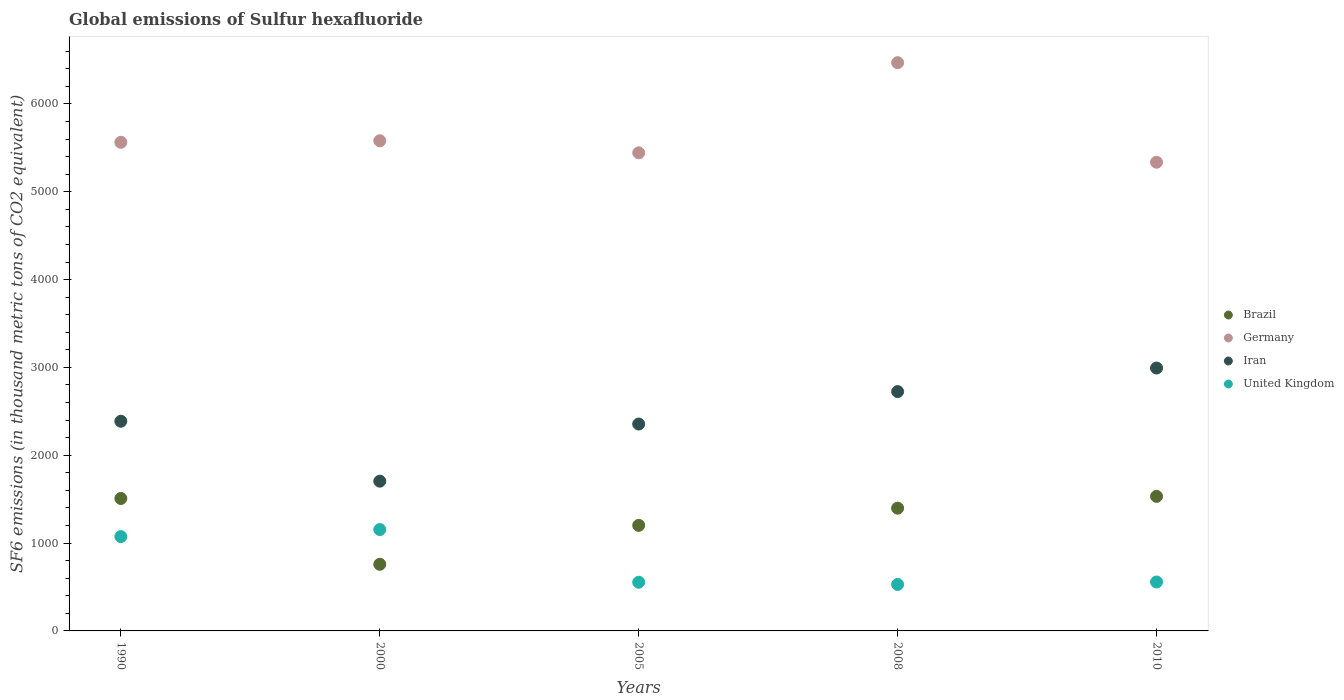How many different coloured dotlines are there?
Your answer should be very brief. 4. What is the global emissions of Sulfur hexafluoride in United Kingdom in 1990?
Your response must be concise. 1073.9. Across all years, what is the maximum global emissions of Sulfur hexafluoride in Iran?
Keep it short and to the point. 2993. Across all years, what is the minimum global emissions of Sulfur hexafluoride in Brazil?
Keep it short and to the point. 758.7. In which year was the global emissions of Sulfur hexafluoride in Brazil maximum?
Provide a short and direct response. 2010. In which year was the global emissions of Sulfur hexafluoride in Brazil minimum?
Ensure brevity in your answer.  2000. What is the total global emissions of Sulfur hexafluoride in Germany in the graph?
Your response must be concise. 2.84e+04. What is the difference between the global emissions of Sulfur hexafluoride in Germany in 2000 and that in 2005?
Provide a succinct answer. 137.2. What is the difference between the global emissions of Sulfur hexafluoride in Brazil in 2005 and the global emissions of Sulfur hexafluoride in Germany in 2010?
Provide a short and direct response. -4134. What is the average global emissions of Sulfur hexafluoride in Iran per year?
Your answer should be compact. 2433.12. In the year 2010, what is the difference between the global emissions of Sulfur hexafluoride in United Kingdom and global emissions of Sulfur hexafluoride in Germany?
Ensure brevity in your answer.  -4779. In how many years, is the global emissions of Sulfur hexafluoride in Brazil greater than 6400 thousand metric tons?
Offer a terse response. 0. What is the ratio of the global emissions of Sulfur hexafluoride in Iran in 2000 to that in 2005?
Offer a terse response. 0.72. Is the global emissions of Sulfur hexafluoride in Germany in 2000 less than that in 2010?
Offer a very short reply. No. What is the difference between the highest and the second highest global emissions of Sulfur hexafluoride in United Kingdom?
Give a very brief answer. 80.2. What is the difference between the highest and the lowest global emissions of Sulfur hexafluoride in Brazil?
Provide a short and direct response. 773.3. Is it the case that in every year, the sum of the global emissions of Sulfur hexafluoride in Iran and global emissions of Sulfur hexafluoride in Germany  is greater than the global emissions of Sulfur hexafluoride in United Kingdom?
Your response must be concise. Yes. Is the global emissions of Sulfur hexafluoride in United Kingdom strictly greater than the global emissions of Sulfur hexafluoride in Germany over the years?
Offer a terse response. No. Is the global emissions of Sulfur hexafluoride in Brazil strictly less than the global emissions of Sulfur hexafluoride in Germany over the years?
Your answer should be very brief. Yes. How many dotlines are there?
Offer a very short reply. 4. How many years are there in the graph?
Give a very brief answer. 5. What is the difference between two consecutive major ticks on the Y-axis?
Your answer should be compact. 1000. Does the graph contain any zero values?
Provide a succinct answer. No. Does the graph contain grids?
Make the answer very short. No. Where does the legend appear in the graph?
Keep it short and to the point. Center right. What is the title of the graph?
Your response must be concise. Global emissions of Sulfur hexafluoride. Does "Egypt, Arab Rep." appear as one of the legend labels in the graph?
Make the answer very short. No. What is the label or title of the Y-axis?
Offer a very short reply. SF6 emissions (in thousand metric tons of CO2 equivalent). What is the SF6 emissions (in thousand metric tons of CO2 equivalent) of Brazil in 1990?
Your answer should be very brief. 1507.9. What is the SF6 emissions (in thousand metric tons of CO2 equivalent) of Germany in 1990?
Provide a succinct answer. 5562.9. What is the SF6 emissions (in thousand metric tons of CO2 equivalent) of Iran in 1990?
Give a very brief answer. 2387.3. What is the SF6 emissions (in thousand metric tons of CO2 equivalent) in United Kingdom in 1990?
Your response must be concise. 1073.9. What is the SF6 emissions (in thousand metric tons of CO2 equivalent) of Brazil in 2000?
Your answer should be very brief. 758.7. What is the SF6 emissions (in thousand metric tons of CO2 equivalent) of Germany in 2000?
Your answer should be compact. 5580.4. What is the SF6 emissions (in thousand metric tons of CO2 equivalent) of Iran in 2000?
Provide a succinct answer. 1704.9. What is the SF6 emissions (in thousand metric tons of CO2 equivalent) in United Kingdom in 2000?
Offer a terse response. 1154.1. What is the SF6 emissions (in thousand metric tons of CO2 equivalent) in Brazil in 2005?
Your answer should be very brief. 1202. What is the SF6 emissions (in thousand metric tons of CO2 equivalent) in Germany in 2005?
Your answer should be compact. 5443.2. What is the SF6 emissions (in thousand metric tons of CO2 equivalent) in Iran in 2005?
Provide a succinct answer. 2355.5. What is the SF6 emissions (in thousand metric tons of CO2 equivalent) of United Kingdom in 2005?
Your answer should be very brief. 554.2. What is the SF6 emissions (in thousand metric tons of CO2 equivalent) of Brazil in 2008?
Ensure brevity in your answer.  1397.3. What is the SF6 emissions (in thousand metric tons of CO2 equivalent) in Germany in 2008?
Make the answer very short. 6469.6. What is the SF6 emissions (in thousand metric tons of CO2 equivalent) in Iran in 2008?
Your answer should be compact. 2724.9. What is the SF6 emissions (in thousand metric tons of CO2 equivalent) in United Kingdom in 2008?
Give a very brief answer. 528.9. What is the SF6 emissions (in thousand metric tons of CO2 equivalent) of Brazil in 2010?
Offer a very short reply. 1532. What is the SF6 emissions (in thousand metric tons of CO2 equivalent) in Germany in 2010?
Your answer should be compact. 5336. What is the SF6 emissions (in thousand metric tons of CO2 equivalent) in Iran in 2010?
Ensure brevity in your answer.  2993. What is the SF6 emissions (in thousand metric tons of CO2 equivalent) of United Kingdom in 2010?
Your answer should be compact. 557. Across all years, what is the maximum SF6 emissions (in thousand metric tons of CO2 equivalent) in Brazil?
Offer a terse response. 1532. Across all years, what is the maximum SF6 emissions (in thousand metric tons of CO2 equivalent) in Germany?
Offer a very short reply. 6469.6. Across all years, what is the maximum SF6 emissions (in thousand metric tons of CO2 equivalent) of Iran?
Offer a terse response. 2993. Across all years, what is the maximum SF6 emissions (in thousand metric tons of CO2 equivalent) in United Kingdom?
Offer a very short reply. 1154.1. Across all years, what is the minimum SF6 emissions (in thousand metric tons of CO2 equivalent) in Brazil?
Make the answer very short. 758.7. Across all years, what is the minimum SF6 emissions (in thousand metric tons of CO2 equivalent) of Germany?
Provide a succinct answer. 5336. Across all years, what is the minimum SF6 emissions (in thousand metric tons of CO2 equivalent) in Iran?
Provide a short and direct response. 1704.9. Across all years, what is the minimum SF6 emissions (in thousand metric tons of CO2 equivalent) of United Kingdom?
Give a very brief answer. 528.9. What is the total SF6 emissions (in thousand metric tons of CO2 equivalent) in Brazil in the graph?
Offer a very short reply. 6397.9. What is the total SF6 emissions (in thousand metric tons of CO2 equivalent) of Germany in the graph?
Your answer should be very brief. 2.84e+04. What is the total SF6 emissions (in thousand metric tons of CO2 equivalent) of Iran in the graph?
Offer a terse response. 1.22e+04. What is the total SF6 emissions (in thousand metric tons of CO2 equivalent) in United Kingdom in the graph?
Offer a terse response. 3868.1. What is the difference between the SF6 emissions (in thousand metric tons of CO2 equivalent) of Brazil in 1990 and that in 2000?
Make the answer very short. 749.2. What is the difference between the SF6 emissions (in thousand metric tons of CO2 equivalent) in Germany in 1990 and that in 2000?
Your answer should be compact. -17.5. What is the difference between the SF6 emissions (in thousand metric tons of CO2 equivalent) in Iran in 1990 and that in 2000?
Ensure brevity in your answer.  682.4. What is the difference between the SF6 emissions (in thousand metric tons of CO2 equivalent) of United Kingdom in 1990 and that in 2000?
Offer a very short reply. -80.2. What is the difference between the SF6 emissions (in thousand metric tons of CO2 equivalent) in Brazil in 1990 and that in 2005?
Your answer should be compact. 305.9. What is the difference between the SF6 emissions (in thousand metric tons of CO2 equivalent) of Germany in 1990 and that in 2005?
Provide a succinct answer. 119.7. What is the difference between the SF6 emissions (in thousand metric tons of CO2 equivalent) of Iran in 1990 and that in 2005?
Your answer should be compact. 31.8. What is the difference between the SF6 emissions (in thousand metric tons of CO2 equivalent) in United Kingdom in 1990 and that in 2005?
Your answer should be compact. 519.7. What is the difference between the SF6 emissions (in thousand metric tons of CO2 equivalent) of Brazil in 1990 and that in 2008?
Make the answer very short. 110.6. What is the difference between the SF6 emissions (in thousand metric tons of CO2 equivalent) in Germany in 1990 and that in 2008?
Offer a terse response. -906.7. What is the difference between the SF6 emissions (in thousand metric tons of CO2 equivalent) in Iran in 1990 and that in 2008?
Make the answer very short. -337.6. What is the difference between the SF6 emissions (in thousand metric tons of CO2 equivalent) in United Kingdom in 1990 and that in 2008?
Keep it short and to the point. 545. What is the difference between the SF6 emissions (in thousand metric tons of CO2 equivalent) in Brazil in 1990 and that in 2010?
Make the answer very short. -24.1. What is the difference between the SF6 emissions (in thousand metric tons of CO2 equivalent) in Germany in 1990 and that in 2010?
Provide a succinct answer. 226.9. What is the difference between the SF6 emissions (in thousand metric tons of CO2 equivalent) of Iran in 1990 and that in 2010?
Provide a short and direct response. -605.7. What is the difference between the SF6 emissions (in thousand metric tons of CO2 equivalent) of United Kingdom in 1990 and that in 2010?
Give a very brief answer. 516.9. What is the difference between the SF6 emissions (in thousand metric tons of CO2 equivalent) in Brazil in 2000 and that in 2005?
Provide a succinct answer. -443.3. What is the difference between the SF6 emissions (in thousand metric tons of CO2 equivalent) in Germany in 2000 and that in 2005?
Offer a terse response. 137.2. What is the difference between the SF6 emissions (in thousand metric tons of CO2 equivalent) in Iran in 2000 and that in 2005?
Provide a short and direct response. -650.6. What is the difference between the SF6 emissions (in thousand metric tons of CO2 equivalent) in United Kingdom in 2000 and that in 2005?
Offer a very short reply. 599.9. What is the difference between the SF6 emissions (in thousand metric tons of CO2 equivalent) in Brazil in 2000 and that in 2008?
Your answer should be compact. -638.6. What is the difference between the SF6 emissions (in thousand metric tons of CO2 equivalent) in Germany in 2000 and that in 2008?
Provide a short and direct response. -889.2. What is the difference between the SF6 emissions (in thousand metric tons of CO2 equivalent) in Iran in 2000 and that in 2008?
Provide a succinct answer. -1020. What is the difference between the SF6 emissions (in thousand metric tons of CO2 equivalent) in United Kingdom in 2000 and that in 2008?
Ensure brevity in your answer.  625.2. What is the difference between the SF6 emissions (in thousand metric tons of CO2 equivalent) of Brazil in 2000 and that in 2010?
Give a very brief answer. -773.3. What is the difference between the SF6 emissions (in thousand metric tons of CO2 equivalent) of Germany in 2000 and that in 2010?
Make the answer very short. 244.4. What is the difference between the SF6 emissions (in thousand metric tons of CO2 equivalent) in Iran in 2000 and that in 2010?
Your response must be concise. -1288.1. What is the difference between the SF6 emissions (in thousand metric tons of CO2 equivalent) of United Kingdom in 2000 and that in 2010?
Offer a very short reply. 597.1. What is the difference between the SF6 emissions (in thousand metric tons of CO2 equivalent) of Brazil in 2005 and that in 2008?
Your answer should be compact. -195.3. What is the difference between the SF6 emissions (in thousand metric tons of CO2 equivalent) in Germany in 2005 and that in 2008?
Ensure brevity in your answer.  -1026.4. What is the difference between the SF6 emissions (in thousand metric tons of CO2 equivalent) in Iran in 2005 and that in 2008?
Your response must be concise. -369.4. What is the difference between the SF6 emissions (in thousand metric tons of CO2 equivalent) in United Kingdom in 2005 and that in 2008?
Ensure brevity in your answer.  25.3. What is the difference between the SF6 emissions (in thousand metric tons of CO2 equivalent) of Brazil in 2005 and that in 2010?
Provide a succinct answer. -330. What is the difference between the SF6 emissions (in thousand metric tons of CO2 equivalent) in Germany in 2005 and that in 2010?
Your answer should be very brief. 107.2. What is the difference between the SF6 emissions (in thousand metric tons of CO2 equivalent) of Iran in 2005 and that in 2010?
Your answer should be very brief. -637.5. What is the difference between the SF6 emissions (in thousand metric tons of CO2 equivalent) in Brazil in 2008 and that in 2010?
Your response must be concise. -134.7. What is the difference between the SF6 emissions (in thousand metric tons of CO2 equivalent) in Germany in 2008 and that in 2010?
Offer a terse response. 1133.6. What is the difference between the SF6 emissions (in thousand metric tons of CO2 equivalent) in Iran in 2008 and that in 2010?
Provide a short and direct response. -268.1. What is the difference between the SF6 emissions (in thousand metric tons of CO2 equivalent) in United Kingdom in 2008 and that in 2010?
Ensure brevity in your answer.  -28.1. What is the difference between the SF6 emissions (in thousand metric tons of CO2 equivalent) of Brazil in 1990 and the SF6 emissions (in thousand metric tons of CO2 equivalent) of Germany in 2000?
Your answer should be very brief. -4072.5. What is the difference between the SF6 emissions (in thousand metric tons of CO2 equivalent) in Brazil in 1990 and the SF6 emissions (in thousand metric tons of CO2 equivalent) in Iran in 2000?
Provide a succinct answer. -197. What is the difference between the SF6 emissions (in thousand metric tons of CO2 equivalent) of Brazil in 1990 and the SF6 emissions (in thousand metric tons of CO2 equivalent) of United Kingdom in 2000?
Your answer should be compact. 353.8. What is the difference between the SF6 emissions (in thousand metric tons of CO2 equivalent) in Germany in 1990 and the SF6 emissions (in thousand metric tons of CO2 equivalent) in Iran in 2000?
Provide a short and direct response. 3858. What is the difference between the SF6 emissions (in thousand metric tons of CO2 equivalent) of Germany in 1990 and the SF6 emissions (in thousand metric tons of CO2 equivalent) of United Kingdom in 2000?
Offer a very short reply. 4408.8. What is the difference between the SF6 emissions (in thousand metric tons of CO2 equivalent) of Iran in 1990 and the SF6 emissions (in thousand metric tons of CO2 equivalent) of United Kingdom in 2000?
Your answer should be very brief. 1233.2. What is the difference between the SF6 emissions (in thousand metric tons of CO2 equivalent) in Brazil in 1990 and the SF6 emissions (in thousand metric tons of CO2 equivalent) in Germany in 2005?
Provide a short and direct response. -3935.3. What is the difference between the SF6 emissions (in thousand metric tons of CO2 equivalent) of Brazil in 1990 and the SF6 emissions (in thousand metric tons of CO2 equivalent) of Iran in 2005?
Make the answer very short. -847.6. What is the difference between the SF6 emissions (in thousand metric tons of CO2 equivalent) of Brazil in 1990 and the SF6 emissions (in thousand metric tons of CO2 equivalent) of United Kingdom in 2005?
Your response must be concise. 953.7. What is the difference between the SF6 emissions (in thousand metric tons of CO2 equivalent) in Germany in 1990 and the SF6 emissions (in thousand metric tons of CO2 equivalent) in Iran in 2005?
Provide a short and direct response. 3207.4. What is the difference between the SF6 emissions (in thousand metric tons of CO2 equivalent) of Germany in 1990 and the SF6 emissions (in thousand metric tons of CO2 equivalent) of United Kingdom in 2005?
Offer a very short reply. 5008.7. What is the difference between the SF6 emissions (in thousand metric tons of CO2 equivalent) of Iran in 1990 and the SF6 emissions (in thousand metric tons of CO2 equivalent) of United Kingdom in 2005?
Provide a succinct answer. 1833.1. What is the difference between the SF6 emissions (in thousand metric tons of CO2 equivalent) in Brazil in 1990 and the SF6 emissions (in thousand metric tons of CO2 equivalent) in Germany in 2008?
Your response must be concise. -4961.7. What is the difference between the SF6 emissions (in thousand metric tons of CO2 equivalent) of Brazil in 1990 and the SF6 emissions (in thousand metric tons of CO2 equivalent) of Iran in 2008?
Provide a succinct answer. -1217. What is the difference between the SF6 emissions (in thousand metric tons of CO2 equivalent) in Brazil in 1990 and the SF6 emissions (in thousand metric tons of CO2 equivalent) in United Kingdom in 2008?
Provide a short and direct response. 979. What is the difference between the SF6 emissions (in thousand metric tons of CO2 equivalent) in Germany in 1990 and the SF6 emissions (in thousand metric tons of CO2 equivalent) in Iran in 2008?
Offer a terse response. 2838. What is the difference between the SF6 emissions (in thousand metric tons of CO2 equivalent) of Germany in 1990 and the SF6 emissions (in thousand metric tons of CO2 equivalent) of United Kingdom in 2008?
Provide a succinct answer. 5034. What is the difference between the SF6 emissions (in thousand metric tons of CO2 equivalent) of Iran in 1990 and the SF6 emissions (in thousand metric tons of CO2 equivalent) of United Kingdom in 2008?
Your answer should be very brief. 1858.4. What is the difference between the SF6 emissions (in thousand metric tons of CO2 equivalent) in Brazil in 1990 and the SF6 emissions (in thousand metric tons of CO2 equivalent) in Germany in 2010?
Your answer should be very brief. -3828.1. What is the difference between the SF6 emissions (in thousand metric tons of CO2 equivalent) of Brazil in 1990 and the SF6 emissions (in thousand metric tons of CO2 equivalent) of Iran in 2010?
Ensure brevity in your answer.  -1485.1. What is the difference between the SF6 emissions (in thousand metric tons of CO2 equivalent) in Brazil in 1990 and the SF6 emissions (in thousand metric tons of CO2 equivalent) in United Kingdom in 2010?
Offer a very short reply. 950.9. What is the difference between the SF6 emissions (in thousand metric tons of CO2 equivalent) in Germany in 1990 and the SF6 emissions (in thousand metric tons of CO2 equivalent) in Iran in 2010?
Make the answer very short. 2569.9. What is the difference between the SF6 emissions (in thousand metric tons of CO2 equivalent) of Germany in 1990 and the SF6 emissions (in thousand metric tons of CO2 equivalent) of United Kingdom in 2010?
Provide a succinct answer. 5005.9. What is the difference between the SF6 emissions (in thousand metric tons of CO2 equivalent) in Iran in 1990 and the SF6 emissions (in thousand metric tons of CO2 equivalent) in United Kingdom in 2010?
Your response must be concise. 1830.3. What is the difference between the SF6 emissions (in thousand metric tons of CO2 equivalent) of Brazil in 2000 and the SF6 emissions (in thousand metric tons of CO2 equivalent) of Germany in 2005?
Your answer should be compact. -4684.5. What is the difference between the SF6 emissions (in thousand metric tons of CO2 equivalent) of Brazil in 2000 and the SF6 emissions (in thousand metric tons of CO2 equivalent) of Iran in 2005?
Your answer should be very brief. -1596.8. What is the difference between the SF6 emissions (in thousand metric tons of CO2 equivalent) of Brazil in 2000 and the SF6 emissions (in thousand metric tons of CO2 equivalent) of United Kingdom in 2005?
Provide a succinct answer. 204.5. What is the difference between the SF6 emissions (in thousand metric tons of CO2 equivalent) in Germany in 2000 and the SF6 emissions (in thousand metric tons of CO2 equivalent) in Iran in 2005?
Offer a very short reply. 3224.9. What is the difference between the SF6 emissions (in thousand metric tons of CO2 equivalent) in Germany in 2000 and the SF6 emissions (in thousand metric tons of CO2 equivalent) in United Kingdom in 2005?
Your answer should be very brief. 5026.2. What is the difference between the SF6 emissions (in thousand metric tons of CO2 equivalent) of Iran in 2000 and the SF6 emissions (in thousand metric tons of CO2 equivalent) of United Kingdom in 2005?
Give a very brief answer. 1150.7. What is the difference between the SF6 emissions (in thousand metric tons of CO2 equivalent) in Brazil in 2000 and the SF6 emissions (in thousand metric tons of CO2 equivalent) in Germany in 2008?
Your answer should be compact. -5710.9. What is the difference between the SF6 emissions (in thousand metric tons of CO2 equivalent) of Brazil in 2000 and the SF6 emissions (in thousand metric tons of CO2 equivalent) of Iran in 2008?
Give a very brief answer. -1966.2. What is the difference between the SF6 emissions (in thousand metric tons of CO2 equivalent) of Brazil in 2000 and the SF6 emissions (in thousand metric tons of CO2 equivalent) of United Kingdom in 2008?
Ensure brevity in your answer.  229.8. What is the difference between the SF6 emissions (in thousand metric tons of CO2 equivalent) in Germany in 2000 and the SF6 emissions (in thousand metric tons of CO2 equivalent) in Iran in 2008?
Your response must be concise. 2855.5. What is the difference between the SF6 emissions (in thousand metric tons of CO2 equivalent) in Germany in 2000 and the SF6 emissions (in thousand metric tons of CO2 equivalent) in United Kingdom in 2008?
Ensure brevity in your answer.  5051.5. What is the difference between the SF6 emissions (in thousand metric tons of CO2 equivalent) in Iran in 2000 and the SF6 emissions (in thousand metric tons of CO2 equivalent) in United Kingdom in 2008?
Provide a succinct answer. 1176. What is the difference between the SF6 emissions (in thousand metric tons of CO2 equivalent) in Brazil in 2000 and the SF6 emissions (in thousand metric tons of CO2 equivalent) in Germany in 2010?
Keep it short and to the point. -4577.3. What is the difference between the SF6 emissions (in thousand metric tons of CO2 equivalent) in Brazil in 2000 and the SF6 emissions (in thousand metric tons of CO2 equivalent) in Iran in 2010?
Offer a very short reply. -2234.3. What is the difference between the SF6 emissions (in thousand metric tons of CO2 equivalent) of Brazil in 2000 and the SF6 emissions (in thousand metric tons of CO2 equivalent) of United Kingdom in 2010?
Offer a very short reply. 201.7. What is the difference between the SF6 emissions (in thousand metric tons of CO2 equivalent) of Germany in 2000 and the SF6 emissions (in thousand metric tons of CO2 equivalent) of Iran in 2010?
Your response must be concise. 2587.4. What is the difference between the SF6 emissions (in thousand metric tons of CO2 equivalent) of Germany in 2000 and the SF6 emissions (in thousand metric tons of CO2 equivalent) of United Kingdom in 2010?
Offer a very short reply. 5023.4. What is the difference between the SF6 emissions (in thousand metric tons of CO2 equivalent) in Iran in 2000 and the SF6 emissions (in thousand metric tons of CO2 equivalent) in United Kingdom in 2010?
Offer a terse response. 1147.9. What is the difference between the SF6 emissions (in thousand metric tons of CO2 equivalent) in Brazil in 2005 and the SF6 emissions (in thousand metric tons of CO2 equivalent) in Germany in 2008?
Give a very brief answer. -5267.6. What is the difference between the SF6 emissions (in thousand metric tons of CO2 equivalent) of Brazil in 2005 and the SF6 emissions (in thousand metric tons of CO2 equivalent) of Iran in 2008?
Provide a short and direct response. -1522.9. What is the difference between the SF6 emissions (in thousand metric tons of CO2 equivalent) of Brazil in 2005 and the SF6 emissions (in thousand metric tons of CO2 equivalent) of United Kingdom in 2008?
Provide a short and direct response. 673.1. What is the difference between the SF6 emissions (in thousand metric tons of CO2 equivalent) in Germany in 2005 and the SF6 emissions (in thousand metric tons of CO2 equivalent) in Iran in 2008?
Make the answer very short. 2718.3. What is the difference between the SF6 emissions (in thousand metric tons of CO2 equivalent) in Germany in 2005 and the SF6 emissions (in thousand metric tons of CO2 equivalent) in United Kingdom in 2008?
Your response must be concise. 4914.3. What is the difference between the SF6 emissions (in thousand metric tons of CO2 equivalent) in Iran in 2005 and the SF6 emissions (in thousand metric tons of CO2 equivalent) in United Kingdom in 2008?
Provide a short and direct response. 1826.6. What is the difference between the SF6 emissions (in thousand metric tons of CO2 equivalent) in Brazil in 2005 and the SF6 emissions (in thousand metric tons of CO2 equivalent) in Germany in 2010?
Your answer should be compact. -4134. What is the difference between the SF6 emissions (in thousand metric tons of CO2 equivalent) in Brazil in 2005 and the SF6 emissions (in thousand metric tons of CO2 equivalent) in Iran in 2010?
Provide a short and direct response. -1791. What is the difference between the SF6 emissions (in thousand metric tons of CO2 equivalent) in Brazil in 2005 and the SF6 emissions (in thousand metric tons of CO2 equivalent) in United Kingdom in 2010?
Offer a very short reply. 645. What is the difference between the SF6 emissions (in thousand metric tons of CO2 equivalent) of Germany in 2005 and the SF6 emissions (in thousand metric tons of CO2 equivalent) of Iran in 2010?
Your answer should be compact. 2450.2. What is the difference between the SF6 emissions (in thousand metric tons of CO2 equivalent) of Germany in 2005 and the SF6 emissions (in thousand metric tons of CO2 equivalent) of United Kingdom in 2010?
Provide a succinct answer. 4886.2. What is the difference between the SF6 emissions (in thousand metric tons of CO2 equivalent) of Iran in 2005 and the SF6 emissions (in thousand metric tons of CO2 equivalent) of United Kingdom in 2010?
Your response must be concise. 1798.5. What is the difference between the SF6 emissions (in thousand metric tons of CO2 equivalent) of Brazil in 2008 and the SF6 emissions (in thousand metric tons of CO2 equivalent) of Germany in 2010?
Keep it short and to the point. -3938.7. What is the difference between the SF6 emissions (in thousand metric tons of CO2 equivalent) of Brazil in 2008 and the SF6 emissions (in thousand metric tons of CO2 equivalent) of Iran in 2010?
Provide a succinct answer. -1595.7. What is the difference between the SF6 emissions (in thousand metric tons of CO2 equivalent) in Brazil in 2008 and the SF6 emissions (in thousand metric tons of CO2 equivalent) in United Kingdom in 2010?
Your answer should be compact. 840.3. What is the difference between the SF6 emissions (in thousand metric tons of CO2 equivalent) in Germany in 2008 and the SF6 emissions (in thousand metric tons of CO2 equivalent) in Iran in 2010?
Provide a succinct answer. 3476.6. What is the difference between the SF6 emissions (in thousand metric tons of CO2 equivalent) of Germany in 2008 and the SF6 emissions (in thousand metric tons of CO2 equivalent) of United Kingdom in 2010?
Your answer should be compact. 5912.6. What is the difference between the SF6 emissions (in thousand metric tons of CO2 equivalent) of Iran in 2008 and the SF6 emissions (in thousand metric tons of CO2 equivalent) of United Kingdom in 2010?
Provide a short and direct response. 2167.9. What is the average SF6 emissions (in thousand metric tons of CO2 equivalent) of Brazil per year?
Your answer should be very brief. 1279.58. What is the average SF6 emissions (in thousand metric tons of CO2 equivalent) in Germany per year?
Offer a terse response. 5678.42. What is the average SF6 emissions (in thousand metric tons of CO2 equivalent) in Iran per year?
Offer a very short reply. 2433.12. What is the average SF6 emissions (in thousand metric tons of CO2 equivalent) of United Kingdom per year?
Your answer should be very brief. 773.62. In the year 1990, what is the difference between the SF6 emissions (in thousand metric tons of CO2 equivalent) in Brazil and SF6 emissions (in thousand metric tons of CO2 equivalent) in Germany?
Keep it short and to the point. -4055. In the year 1990, what is the difference between the SF6 emissions (in thousand metric tons of CO2 equivalent) of Brazil and SF6 emissions (in thousand metric tons of CO2 equivalent) of Iran?
Keep it short and to the point. -879.4. In the year 1990, what is the difference between the SF6 emissions (in thousand metric tons of CO2 equivalent) in Brazil and SF6 emissions (in thousand metric tons of CO2 equivalent) in United Kingdom?
Provide a short and direct response. 434. In the year 1990, what is the difference between the SF6 emissions (in thousand metric tons of CO2 equivalent) of Germany and SF6 emissions (in thousand metric tons of CO2 equivalent) of Iran?
Your answer should be compact. 3175.6. In the year 1990, what is the difference between the SF6 emissions (in thousand metric tons of CO2 equivalent) in Germany and SF6 emissions (in thousand metric tons of CO2 equivalent) in United Kingdom?
Provide a succinct answer. 4489. In the year 1990, what is the difference between the SF6 emissions (in thousand metric tons of CO2 equivalent) in Iran and SF6 emissions (in thousand metric tons of CO2 equivalent) in United Kingdom?
Your response must be concise. 1313.4. In the year 2000, what is the difference between the SF6 emissions (in thousand metric tons of CO2 equivalent) in Brazil and SF6 emissions (in thousand metric tons of CO2 equivalent) in Germany?
Your response must be concise. -4821.7. In the year 2000, what is the difference between the SF6 emissions (in thousand metric tons of CO2 equivalent) of Brazil and SF6 emissions (in thousand metric tons of CO2 equivalent) of Iran?
Make the answer very short. -946.2. In the year 2000, what is the difference between the SF6 emissions (in thousand metric tons of CO2 equivalent) in Brazil and SF6 emissions (in thousand metric tons of CO2 equivalent) in United Kingdom?
Make the answer very short. -395.4. In the year 2000, what is the difference between the SF6 emissions (in thousand metric tons of CO2 equivalent) of Germany and SF6 emissions (in thousand metric tons of CO2 equivalent) of Iran?
Your answer should be very brief. 3875.5. In the year 2000, what is the difference between the SF6 emissions (in thousand metric tons of CO2 equivalent) in Germany and SF6 emissions (in thousand metric tons of CO2 equivalent) in United Kingdom?
Provide a succinct answer. 4426.3. In the year 2000, what is the difference between the SF6 emissions (in thousand metric tons of CO2 equivalent) of Iran and SF6 emissions (in thousand metric tons of CO2 equivalent) of United Kingdom?
Provide a succinct answer. 550.8. In the year 2005, what is the difference between the SF6 emissions (in thousand metric tons of CO2 equivalent) in Brazil and SF6 emissions (in thousand metric tons of CO2 equivalent) in Germany?
Give a very brief answer. -4241.2. In the year 2005, what is the difference between the SF6 emissions (in thousand metric tons of CO2 equivalent) of Brazil and SF6 emissions (in thousand metric tons of CO2 equivalent) of Iran?
Your response must be concise. -1153.5. In the year 2005, what is the difference between the SF6 emissions (in thousand metric tons of CO2 equivalent) in Brazil and SF6 emissions (in thousand metric tons of CO2 equivalent) in United Kingdom?
Offer a very short reply. 647.8. In the year 2005, what is the difference between the SF6 emissions (in thousand metric tons of CO2 equivalent) in Germany and SF6 emissions (in thousand metric tons of CO2 equivalent) in Iran?
Provide a short and direct response. 3087.7. In the year 2005, what is the difference between the SF6 emissions (in thousand metric tons of CO2 equivalent) of Germany and SF6 emissions (in thousand metric tons of CO2 equivalent) of United Kingdom?
Make the answer very short. 4889. In the year 2005, what is the difference between the SF6 emissions (in thousand metric tons of CO2 equivalent) in Iran and SF6 emissions (in thousand metric tons of CO2 equivalent) in United Kingdom?
Ensure brevity in your answer.  1801.3. In the year 2008, what is the difference between the SF6 emissions (in thousand metric tons of CO2 equivalent) of Brazil and SF6 emissions (in thousand metric tons of CO2 equivalent) of Germany?
Ensure brevity in your answer.  -5072.3. In the year 2008, what is the difference between the SF6 emissions (in thousand metric tons of CO2 equivalent) of Brazil and SF6 emissions (in thousand metric tons of CO2 equivalent) of Iran?
Offer a terse response. -1327.6. In the year 2008, what is the difference between the SF6 emissions (in thousand metric tons of CO2 equivalent) in Brazil and SF6 emissions (in thousand metric tons of CO2 equivalent) in United Kingdom?
Offer a very short reply. 868.4. In the year 2008, what is the difference between the SF6 emissions (in thousand metric tons of CO2 equivalent) of Germany and SF6 emissions (in thousand metric tons of CO2 equivalent) of Iran?
Give a very brief answer. 3744.7. In the year 2008, what is the difference between the SF6 emissions (in thousand metric tons of CO2 equivalent) in Germany and SF6 emissions (in thousand metric tons of CO2 equivalent) in United Kingdom?
Your answer should be compact. 5940.7. In the year 2008, what is the difference between the SF6 emissions (in thousand metric tons of CO2 equivalent) in Iran and SF6 emissions (in thousand metric tons of CO2 equivalent) in United Kingdom?
Your answer should be compact. 2196. In the year 2010, what is the difference between the SF6 emissions (in thousand metric tons of CO2 equivalent) of Brazil and SF6 emissions (in thousand metric tons of CO2 equivalent) of Germany?
Your response must be concise. -3804. In the year 2010, what is the difference between the SF6 emissions (in thousand metric tons of CO2 equivalent) in Brazil and SF6 emissions (in thousand metric tons of CO2 equivalent) in Iran?
Your answer should be very brief. -1461. In the year 2010, what is the difference between the SF6 emissions (in thousand metric tons of CO2 equivalent) in Brazil and SF6 emissions (in thousand metric tons of CO2 equivalent) in United Kingdom?
Offer a terse response. 975. In the year 2010, what is the difference between the SF6 emissions (in thousand metric tons of CO2 equivalent) in Germany and SF6 emissions (in thousand metric tons of CO2 equivalent) in Iran?
Your answer should be very brief. 2343. In the year 2010, what is the difference between the SF6 emissions (in thousand metric tons of CO2 equivalent) of Germany and SF6 emissions (in thousand metric tons of CO2 equivalent) of United Kingdom?
Keep it short and to the point. 4779. In the year 2010, what is the difference between the SF6 emissions (in thousand metric tons of CO2 equivalent) in Iran and SF6 emissions (in thousand metric tons of CO2 equivalent) in United Kingdom?
Offer a very short reply. 2436. What is the ratio of the SF6 emissions (in thousand metric tons of CO2 equivalent) in Brazil in 1990 to that in 2000?
Give a very brief answer. 1.99. What is the ratio of the SF6 emissions (in thousand metric tons of CO2 equivalent) in Germany in 1990 to that in 2000?
Your answer should be compact. 1. What is the ratio of the SF6 emissions (in thousand metric tons of CO2 equivalent) in Iran in 1990 to that in 2000?
Provide a short and direct response. 1.4. What is the ratio of the SF6 emissions (in thousand metric tons of CO2 equivalent) in United Kingdom in 1990 to that in 2000?
Ensure brevity in your answer.  0.93. What is the ratio of the SF6 emissions (in thousand metric tons of CO2 equivalent) in Brazil in 1990 to that in 2005?
Offer a very short reply. 1.25. What is the ratio of the SF6 emissions (in thousand metric tons of CO2 equivalent) in Iran in 1990 to that in 2005?
Provide a short and direct response. 1.01. What is the ratio of the SF6 emissions (in thousand metric tons of CO2 equivalent) in United Kingdom in 1990 to that in 2005?
Provide a short and direct response. 1.94. What is the ratio of the SF6 emissions (in thousand metric tons of CO2 equivalent) of Brazil in 1990 to that in 2008?
Make the answer very short. 1.08. What is the ratio of the SF6 emissions (in thousand metric tons of CO2 equivalent) in Germany in 1990 to that in 2008?
Provide a succinct answer. 0.86. What is the ratio of the SF6 emissions (in thousand metric tons of CO2 equivalent) in Iran in 1990 to that in 2008?
Provide a succinct answer. 0.88. What is the ratio of the SF6 emissions (in thousand metric tons of CO2 equivalent) in United Kingdom in 1990 to that in 2008?
Give a very brief answer. 2.03. What is the ratio of the SF6 emissions (in thousand metric tons of CO2 equivalent) of Brazil in 1990 to that in 2010?
Your answer should be compact. 0.98. What is the ratio of the SF6 emissions (in thousand metric tons of CO2 equivalent) of Germany in 1990 to that in 2010?
Provide a short and direct response. 1.04. What is the ratio of the SF6 emissions (in thousand metric tons of CO2 equivalent) of Iran in 1990 to that in 2010?
Your answer should be compact. 0.8. What is the ratio of the SF6 emissions (in thousand metric tons of CO2 equivalent) in United Kingdom in 1990 to that in 2010?
Provide a succinct answer. 1.93. What is the ratio of the SF6 emissions (in thousand metric tons of CO2 equivalent) of Brazil in 2000 to that in 2005?
Your answer should be very brief. 0.63. What is the ratio of the SF6 emissions (in thousand metric tons of CO2 equivalent) in Germany in 2000 to that in 2005?
Provide a short and direct response. 1.03. What is the ratio of the SF6 emissions (in thousand metric tons of CO2 equivalent) in Iran in 2000 to that in 2005?
Provide a short and direct response. 0.72. What is the ratio of the SF6 emissions (in thousand metric tons of CO2 equivalent) of United Kingdom in 2000 to that in 2005?
Provide a succinct answer. 2.08. What is the ratio of the SF6 emissions (in thousand metric tons of CO2 equivalent) of Brazil in 2000 to that in 2008?
Offer a terse response. 0.54. What is the ratio of the SF6 emissions (in thousand metric tons of CO2 equivalent) in Germany in 2000 to that in 2008?
Offer a terse response. 0.86. What is the ratio of the SF6 emissions (in thousand metric tons of CO2 equivalent) of Iran in 2000 to that in 2008?
Keep it short and to the point. 0.63. What is the ratio of the SF6 emissions (in thousand metric tons of CO2 equivalent) in United Kingdom in 2000 to that in 2008?
Provide a short and direct response. 2.18. What is the ratio of the SF6 emissions (in thousand metric tons of CO2 equivalent) of Brazil in 2000 to that in 2010?
Your response must be concise. 0.5. What is the ratio of the SF6 emissions (in thousand metric tons of CO2 equivalent) in Germany in 2000 to that in 2010?
Offer a very short reply. 1.05. What is the ratio of the SF6 emissions (in thousand metric tons of CO2 equivalent) of Iran in 2000 to that in 2010?
Your answer should be very brief. 0.57. What is the ratio of the SF6 emissions (in thousand metric tons of CO2 equivalent) of United Kingdom in 2000 to that in 2010?
Your answer should be very brief. 2.07. What is the ratio of the SF6 emissions (in thousand metric tons of CO2 equivalent) in Brazil in 2005 to that in 2008?
Your answer should be compact. 0.86. What is the ratio of the SF6 emissions (in thousand metric tons of CO2 equivalent) in Germany in 2005 to that in 2008?
Provide a succinct answer. 0.84. What is the ratio of the SF6 emissions (in thousand metric tons of CO2 equivalent) in Iran in 2005 to that in 2008?
Offer a very short reply. 0.86. What is the ratio of the SF6 emissions (in thousand metric tons of CO2 equivalent) in United Kingdom in 2005 to that in 2008?
Offer a very short reply. 1.05. What is the ratio of the SF6 emissions (in thousand metric tons of CO2 equivalent) of Brazil in 2005 to that in 2010?
Your answer should be compact. 0.78. What is the ratio of the SF6 emissions (in thousand metric tons of CO2 equivalent) in Germany in 2005 to that in 2010?
Ensure brevity in your answer.  1.02. What is the ratio of the SF6 emissions (in thousand metric tons of CO2 equivalent) in Iran in 2005 to that in 2010?
Ensure brevity in your answer.  0.79. What is the ratio of the SF6 emissions (in thousand metric tons of CO2 equivalent) in United Kingdom in 2005 to that in 2010?
Your response must be concise. 0.99. What is the ratio of the SF6 emissions (in thousand metric tons of CO2 equivalent) in Brazil in 2008 to that in 2010?
Your answer should be very brief. 0.91. What is the ratio of the SF6 emissions (in thousand metric tons of CO2 equivalent) in Germany in 2008 to that in 2010?
Offer a terse response. 1.21. What is the ratio of the SF6 emissions (in thousand metric tons of CO2 equivalent) in Iran in 2008 to that in 2010?
Offer a terse response. 0.91. What is the ratio of the SF6 emissions (in thousand metric tons of CO2 equivalent) of United Kingdom in 2008 to that in 2010?
Ensure brevity in your answer.  0.95. What is the difference between the highest and the second highest SF6 emissions (in thousand metric tons of CO2 equivalent) in Brazil?
Provide a short and direct response. 24.1. What is the difference between the highest and the second highest SF6 emissions (in thousand metric tons of CO2 equivalent) of Germany?
Provide a succinct answer. 889.2. What is the difference between the highest and the second highest SF6 emissions (in thousand metric tons of CO2 equivalent) of Iran?
Your answer should be very brief. 268.1. What is the difference between the highest and the second highest SF6 emissions (in thousand metric tons of CO2 equivalent) of United Kingdom?
Ensure brevity in your answer.  80.2. What is the difference between the highest and the lowest SF6 emissions (in thousand metric tons of CO2 equivalent) of Brazil?
Offer a terse response. 773.3. What is the difference between the highest and the lowest SF6 emissions (in thousand metric tons of CO2 equivalent) of Germany?
Keep it short and to the point. 1133.6. What is the difference between the highest and the lowest SF6 emissions (in thousand metric tons of CO2 equivalent) in Iran?
Offer a terse response. 1288.1. What is the difference between the highest and the lowest SF6 emissions (in thousand metric tons of CO2 equivalent) of United Kingdom?
Give a very brief answer. 625.2. 